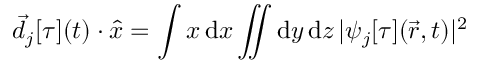<formula> <loc_0><loc_0><loc_500><loc_500>\vec { d } _ { j } [ \tau ] ( t ) \cdot \hat { x } = \int x \, d x \iint d y \, d z \, | \psi _ { j } [ \tau ] ( \vec { r } , t ) | ^ { 2 }</formula> 